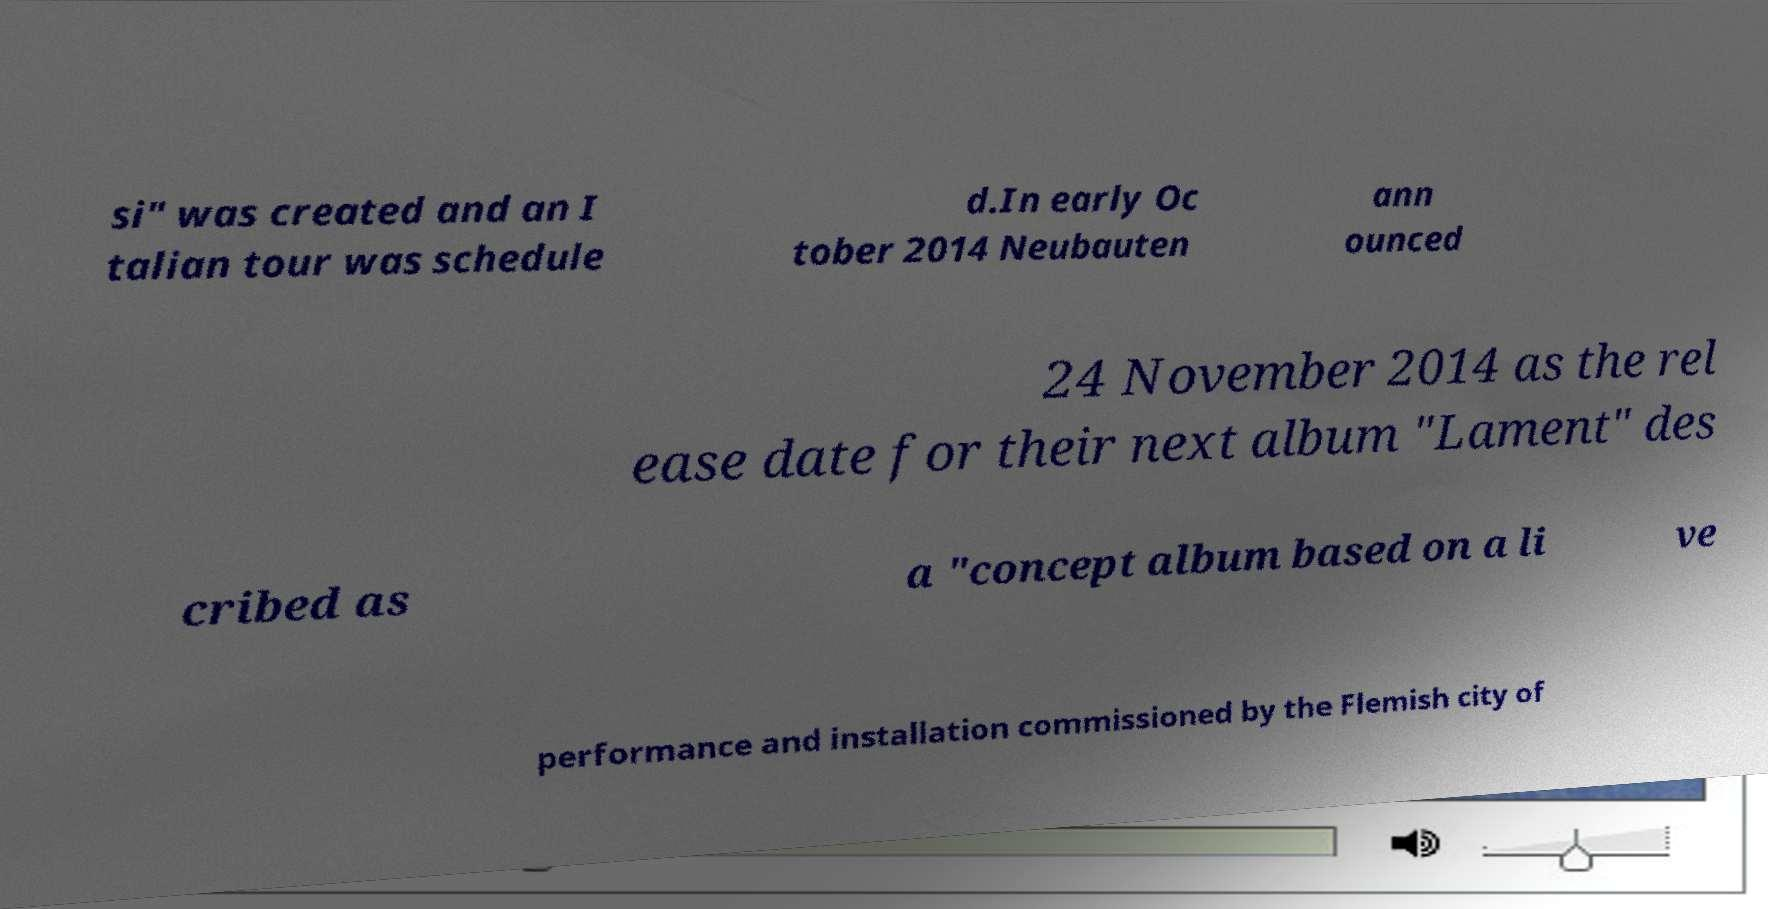For documentation purposes, I need the text within this image transcribed. Could you provide that? si" was created and an I talian tour was schedule d.In early Oc tober 2014 Neubauten ann ounced 24 November 2014 as the rel ease date for their next album "Lament" des cribed as a "concept album based on a li ve performance and installation commissioned by the Flemish city of 